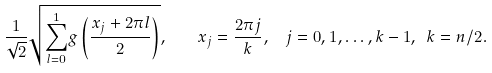Convert formula to latex. <formula><loc_0><loc_0><loc_500><loc_500>\frac { 1 } { \sqrt { 2 } } \sqrt { \overset { 1 } { \underset { l = 0 } \sum } g \left ( \frac { x _ { j } + 2 \pi l } { 2 } \right ) } , \quad x _ { j } = \frac { 2 \pi j } { k } , \ \ j = 0 , 1 , \dots , k - 1 , \ k = n / 2 .</formula> 